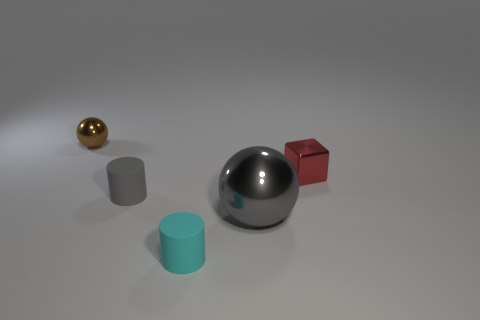Subtract all spheres. How many objects are left? 3 Subtract all cyan balls. How many gray cylinders are left? 1 Add 1 small red blocks. How many small red blocks are left? 2 Add 5 small matte cylinders. How many small matte cylinders exist? 7 Add 4 brown metallic spheres. How many objects exist? 9 Subtract all brown balls. How many balls are left? 1 Subtract 0 yellow spheres. How many objects are left? 5 Subtract all purple cylinders. Subtract all green cubes. How many cylinders are left? 2 Subtract all small things. Subtract all big gray objects. How many objects are left? 0 